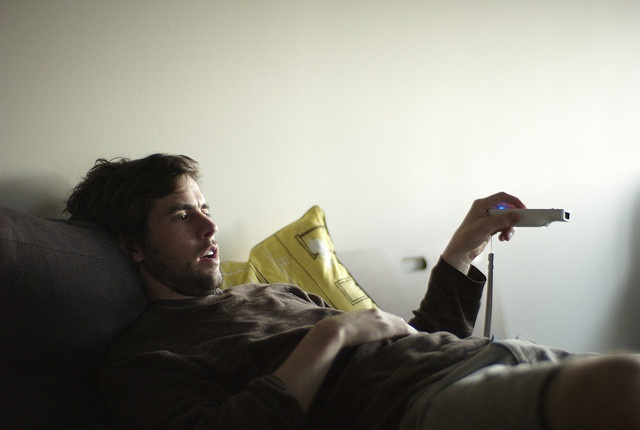Describe the objects in this image and their specific colors. I can see people in gray, black, and darkgray tones, couch in gray and black tones, and remote in gray, black, and lightgray tones in this image. 